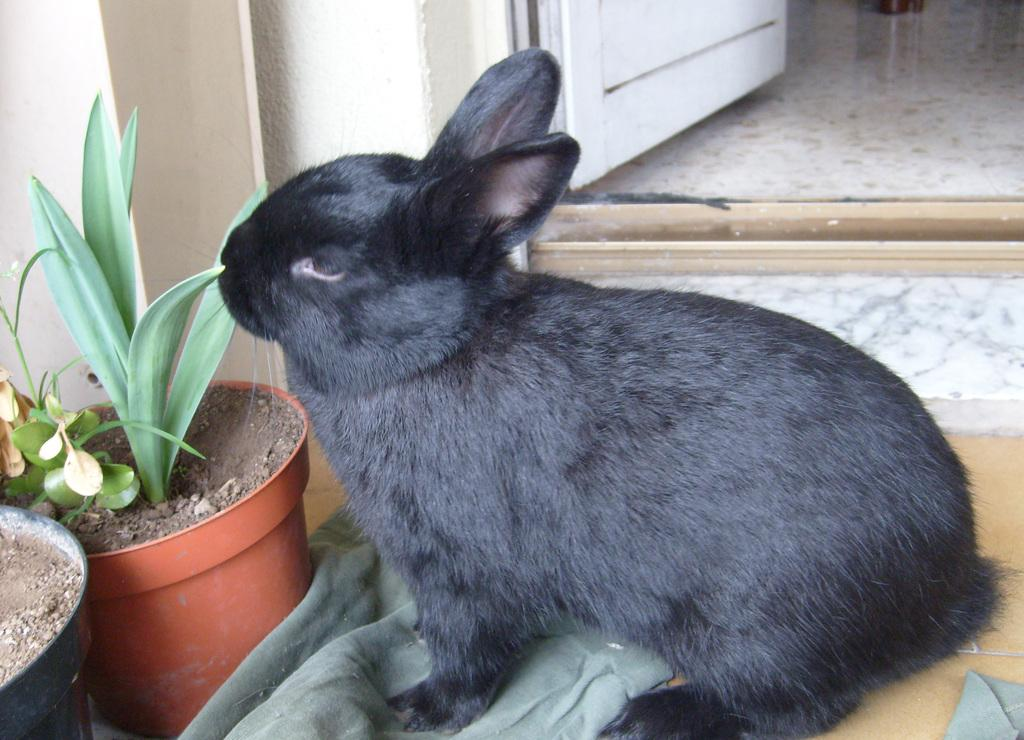What type of living creature is in the image? There is an animal in the image. What is the animal interacting with in the image? The animal is interacting with a cloth in the image. What other objects can be seen in the image? There are plants, pots, a door, and a marble floor in the image. What type of eggs can be seen in the image? There are no eggs present in the image. Is the cat in the image seeking approval from the animal? There is no cat present in the image, so it cannot be seeking approval from the animal. 